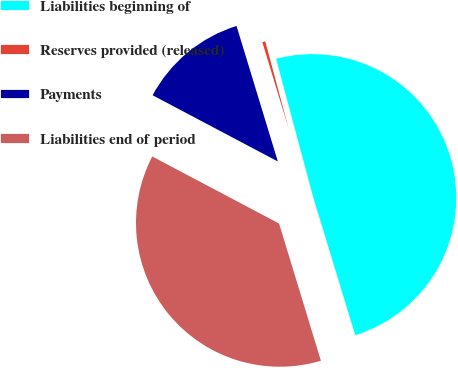Convert chart. <chart><loc_0><loc_0><loc_500><loc_500><pie_chart><fcel>Liabilities beginning of<fcel>Reserves provided (released)<fcel>Payments<fcel>Liabilities end of period<nl><fcel>49.46%<fcel>0.54%<fcel>12.55%<fcel>37.45%<nl></chart> 